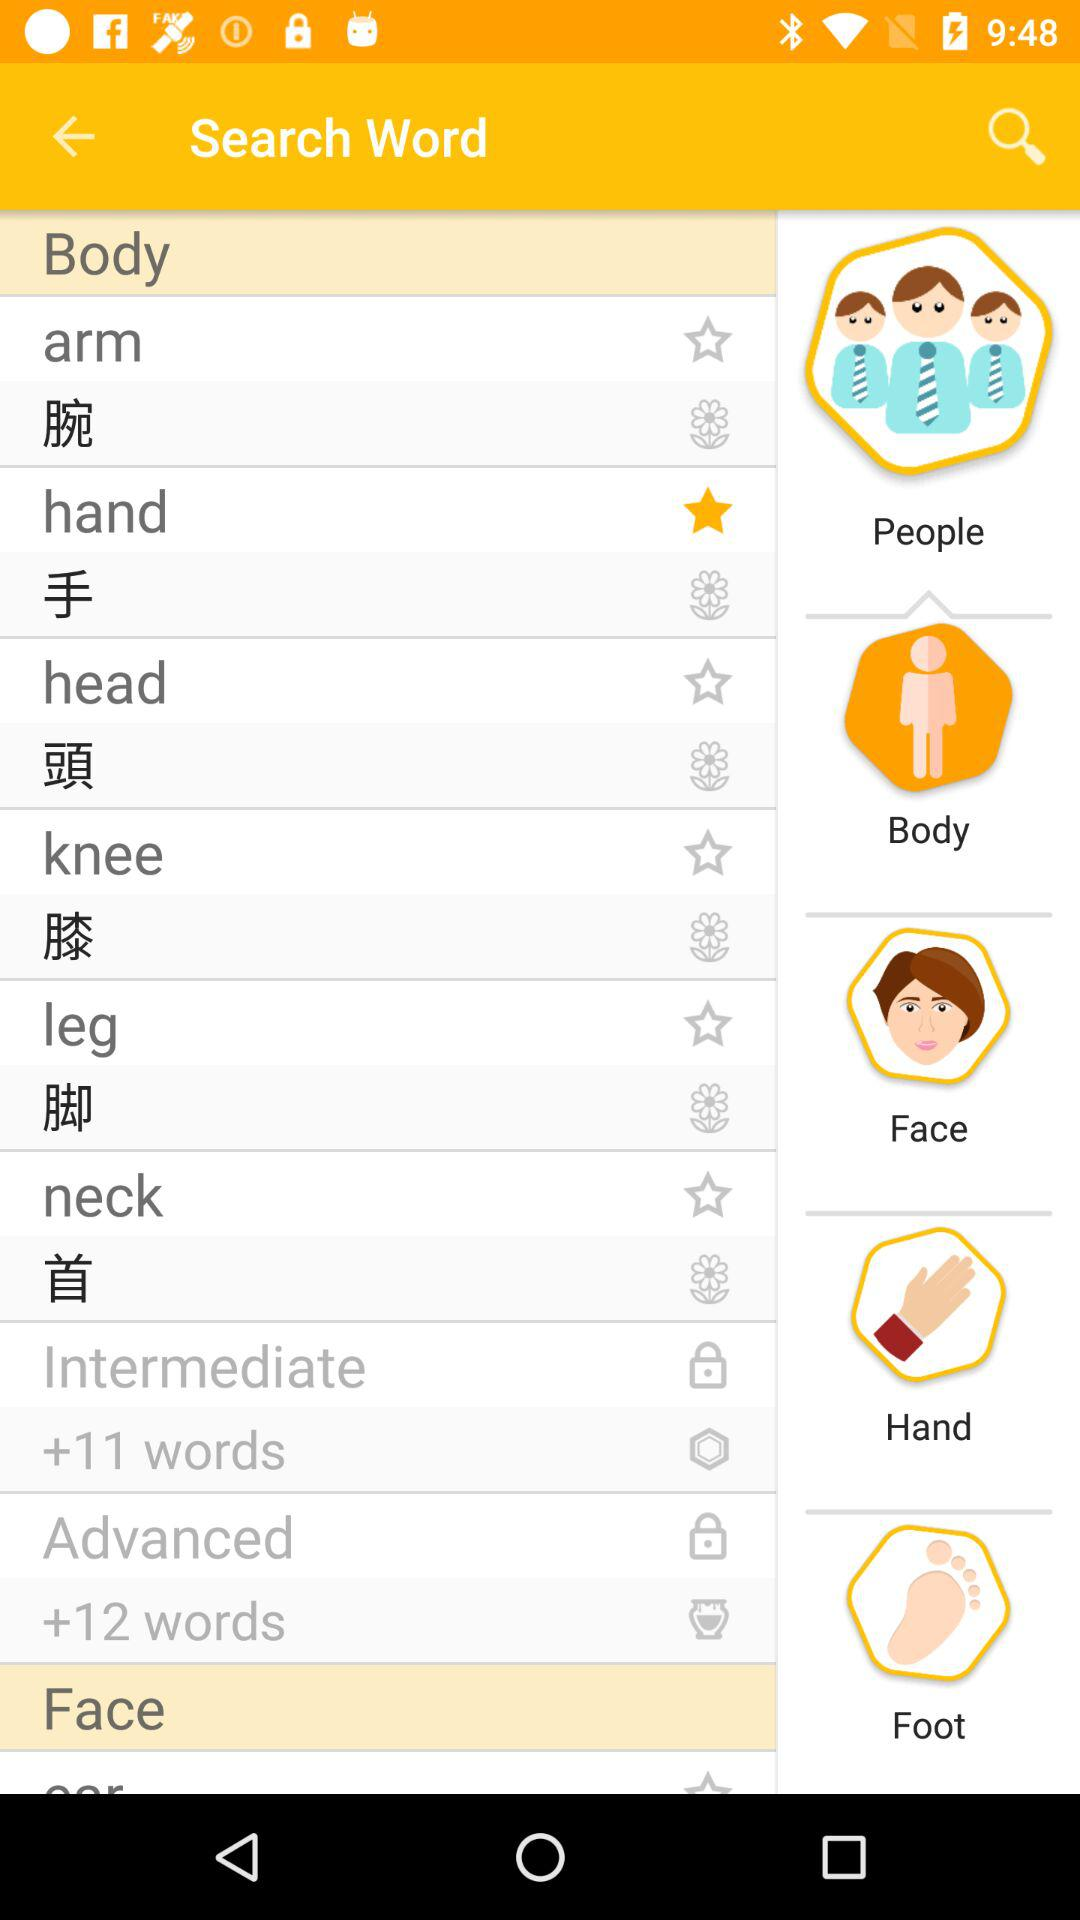Which word is marked as a favorite? The word that is marked as a favorite is "hand". 